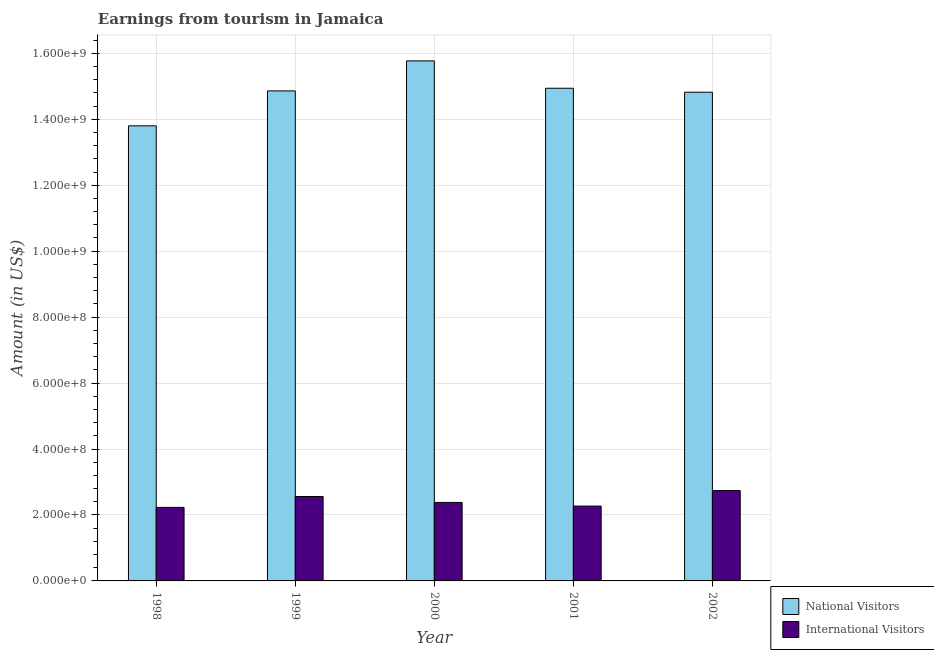How many different coloured bars are there?
Make the answer very short. 2. How many groups of bars are there?
Your answer should be very brief. 5. Are the number of bars on each tick of the X-axis equal?
Your response must be concise. Yes. How many bars are there on the 4th tick from the left?
Offer a terse response. 2. How many bars are there on the 2nd tick from the right?
Give a very brief answer. 2. What is the label of the 5th group of bars from the left?
Offer a very short reply. 2002. In how many cases, is the number of bars for a given year not equal to the number of legend labels?
Offer a terse response. 0. What is the amount earned from national visitors in 2002?
Make the answer very short. 1.48e+09. Across all years, what is the maximum amount earned from national visitors?
Give a very brief answer. 1.58e+09. Across all years, what is the minimum amount earned from national visitors?
Make the answer very short. 1.38e+09. In which year was the amount earned from national visitors maximum?
Your answer should be compact. 2000. What is the total amount earned from international visitors in the graph?
Ensure brevity in your answer.  1.22e+09. What is the difference between the amount earned from international visitors in 1998 and that in 2001?
Your answer should be compact. -4.00e+06. What is the difference between the amount earned from international visitors in 2001 and the amount earned from national visitors in 1998?
Offer a very short reply. 4.00e+06. What is the average amount earned from national visitors per year?
Give a very brief answer. 1.48e+09. In the year 1999, what is the difference between the amount earned from national visitors and amount earned from international visitors?
Provide a succinct answer. 0. In how many years, is the amount earned from international visitors greater than 800000000 US$?
Your answer should be very brief. 0. What is the ratio of the amount earned from national visitors in 2000 to that in 2002?
Offer a terse response. 1.06. What is the difference between the highest and the second highest amount earned from international visitors?
Ensure brevity in your answer.  1.80e+07. What is the difference between the highest and the lowest amount earned from national visitors?
Your answer should be very brief. 1.97e+08. In how many years, is the amount earned from international visitors greater than the average amount earned from international visitors taken over all years?
Keep it short and to the point. 2. Is the sum of the amount earned from international visitors in 2000 and 2002 greater than the maximum amount earned from national visitors across all years?
Your answer should be very brief. Yes. What does the 2nd bar from the left in 2000 represents?
Make the answer very short. International Visitors. What does the 2nd bar from the right in 1998 represents?
Offer a very short reply. National Visitors. How many bars are there?
Make the answer very short. 10. Are all the bars in the graph horizontal?
Keep it short and to the point. No. How many years are there in the graph?
Offer a very short reply. 5. What is the difference between two consecutive major ticks on the Y-axis?
Provide a succinct answer. 2.00e+08. Does the graph contain any zero values?
Offer a terse response. No. How many legend labels are there?
Provide a succinct answer. 2. How are the legend labels stacked?
Provide a succinct answer. Vertical. What is the title of the graph?
Offer a very short reply. Earnings from tourism in Jamaica. What is the label or title of the X-axis?
Your answer should be very brief. Year. What is the label or title of the Y-axis?
Provide a succinct answer. Amount (in US$). What is the Amount (in US$) in National Visitors in 1998?
Give a very brief answer. 1.38e+09. What is the Amount (in US$) in International Visitors in 1998?
Ensure brevity in your answer.  2.23e+08. What is the Amount (in US$) in National Visitors in 1999?
Offer a very short reply. 1.49e+09. What is the Amount (in US$) of International Visitors in 1999?
Provide a short and direct response. 2.56e+08. What is the Amount (in US$) in National Visitors in 2000?
Offer a terse response. 1.58e+09. What is the Amount (in US$) of International Visitors in 2000?
Ensure brevity in your answer.  2.38e+08. What is the Amount (in US$) of National Visitors in 2001?
Give a very brief answer. 1.49e+09. What is the Amount (in US$) in International Visitors in 2001?
Give a very brief answer. 2.27e+08. What is the Amount (in US$) in National Visitors in 2002?
Offer a very short reply. 1.48e+09. What is the Amount (in US$) in International Visitors in 2002?
Keep it short and to the point. 2.74e+08. Across all years, what is the maximum Amount (in US$) of National Visitors?
Your answer should be very brief. 1.58e+09. Across all years, what is the maximum Amount (in US$) of International Visitors?
Offer a very short reply. 2.74e+08. Across all years, what is the minimum Amount (in US$) of National Visitors?
Your response must be concise. 1.38e+09. Across all years, what is the minimum Amount (in US$) of International Visitors?
Provide a short and direct response. 2.23e+08. What is the total Amount (in US$) of National Visitors in the graph?
Your answer should be very brief. 7.42e+09. What is the total Amount (in US$) in International Visitors in the graph?
Ensure brevity in your answer.  1.22e+09. What is the difference between the Amount (in US$) in National Visitors in 1998 and that in 1999?
Offer a terse response. -1.06e+08. What is the difference between the Amount (in US$) in International Visitors in 1998 and that in 1999?
Give a very brief answer. -3.30e+07. What is the difference between the Amount (in US$) of National Visitors in 1998 and that in 2000?
Your answer should be compact. -1.97e+08. What is the difference between the Amount (in US$) of International Visitors in 1998 and that in 2000?
Offer a terse response. -1.50e+07. What is the difference between the Amount (in US$) of National Visitors in 1998 and that in 2001?
Provide a short and direct response. -1.14e+08. What is the difference between the Amount (in US$) in International Visitors in 1998 and that in 2001?
Ensure brevity in your answer.  -4.00e+06. What is the difference between the Amount (in US$) of National Visitors in 1998 and that in 2002?
Give a very brief answer. -1.02e+08. What is the difference between the Amount (in US$) in International Visitors in 1998 and that in 2002?
Offer a very short reply. -5.10e+07. What is the difference between the Amount (in US$) in National Visitors in 1999 and that in 2000?
Make the answer very short. -9.10e+07. What is the difference between the Amount (in US$) in International Visitors in 1999 and that in 2000?
Keep it short and to the point. 1.80e+07. What is the difference between the Amount (in US$) in National Visitors in 1999 and that in 2001?
Make the answer very short. -8.00e+06. What is the difference between the Amount (in US$) of International Visitors in 1999 and that in 2001?
Your answer should be very brief. 2.90e+07. What is the difference between the Amount (in US$) in International Visitors in 1999 and that in 2002?
Make the answer very short. -1.80e+07. What is the difference between the Amount (in US$) in National Visitors in 2000 and that in 2001?
Your response must be concise. 8.30e+07. What is the difference between the Amount (in US$) in International Visitors in 2000 and that in 2001?
Provide a short and direct response. 1.10e+07. What is the difference between the Amount (in US$) in National Visitors in 2000 and that in 2002?
Make the answer very short. 9.50e+07. What is the difference between the Amount (in US$) in International Visitors in 2000 and that in 2002?
Your answer should be very brief. -3.60e+07. What is the difference between the Amount (in US$) of International Visitors in 2001 and that in 2002?
Ensure brevity in your answer.  -4.70e+07. What is the difference between the Amount (in US$) of National Visitors in 1998 and the Amount (in US$) of International Visitors in 1999?
Offer a very short reply. 1.12e+09. What is the difference between the Amount (in US$) in National Visitors in 1998 and the Amount (in US$) in International Visitors in 2000?
Your response must be concise. 1.14e+09. What is the difference between the Amount (in US$) in National Visitors in 1998 and the Amount (in US$) in International Visitors in 2001?
Ensure brevity in your answer.  1.15e+09. What is the difference between the Amount (in US$) of National Visitors in 1998 and the Amount (in US$) of International Visitors in 2002?
Your answer should be compact. 1.11e+09. What is the difference between the Amount (in US$) of National Visitors in 1999 and the Amount (in US$) of International Visitors in 2000?
Keep it short and to the point. 1.25e+09. What is the difference between the Amount (in US$) of National Visitors in 1999 and the Amount (in US$) of International Visitors in 2001?
Keep it short and to the point. 1.26e+09. What is the difference between the Amount (in US$) in National Visitors in 1999 and the Amount (in US$) in International Visitors in 2002?
Provide a short and direct response. 1.21e+09. What is the difference between the Amount (in US$) in National Visitors in 2000 and the Amount (in US$) in International Visitors in 2001?
Offer a very short reply. 1.35e+09. What is the difference between the Amount (in US$) in National Visitors in 2000 and the Amount (in US$) in International Visitors in 2002?
Keep it short and to the point. 1.30e+09. What is the difference between the Amount (in US$) of National Visitors in 2001 and the Amount (in US$) of International Visitors in 2002?
Offer a terse response. 1.22e+09. What is the average Amount (in US$) in National Visitors per year?
Your answer should be compact. 1.48e+09. What is the average Amount (in US$) of International Visitors per year?
Provide a short and direct response. 2.44e+08. In the year 1998, what is the difference between the Amount (in US$) in National Visitors and Amount (in US$) in International Visitors?
Ensure brevity in your answer.  1.16e+09. In the year 1999, what is the difference between the Amount (in US$) in National Visitors and Amount (in US$) in International Visitors?
Give a very brief answer. 1.23e+09. In the year 2000, what is the difference between the Amount (in US$) in National Visitors and Amount (in US$) in International Visitors?
Your response must be concise. 1.34e+09. In the year 2001, what is the difference between the Amount (in US$) in National Visitors and Amount (in US$) in International Visitors?
Ensure brevity in your answer.  1.27e+09. In the year 2002, what is the difference between the Amount (in US$) in National Visitors and Amount (in US$) in International Visitors?
Offer a terse response. 1.21e+09. What is the ratio of the Amount (in US$) of National Visitors in 1998 to that in 1999?
Offer a very short reply. 0.93. What is the ratio of the Amount (in US$) of International Visitors in 1998 to that in 1999?
Give a very brief answer. 0.87. What is the ratio of the Amount (in US$) in National Visitors in 1998 to that in 2000?
Offer a terse response. 0.88. What is the ratio of the Amount (in US$) in International Visitors in 1998 to that in 2000?
Your answer should be compact. 0.94. What is the ratio of the Amount (in US$) in National Visitors in 1998 to that in 2001?
Give a very brief answer. 0.92. What is the ratio of the Amount (in US$) in International Visitors in 1998 to that in 2001?
Make the answer very short. 0.98. What is the ratio of the Amount (in US$) of National Visitors in 1998 to that in 2002?
Ensure brevity in your answer.  0.93. What is the ratio of the Amount (in US$) in International Visitors in 1998 to that in 2002?
Give a very brief answer. 0.81. What is the ratio of the Amount (in US$) in National Visitors in 1999 to that in 2000?
Offer a terse response. 0.94. What is the ratio of the Amount (in US$) in International Visitors in 1999 to that in 2000?
Keep it short and to the point. 1.08. What is the ratio of the Amount (in US$) in National Visitors in 1999 to that in 2001?
Your answer should be very brief. 0.99. What is the ratio of the Amount (in US$) in International Visitors in 1999 to that in 2001?
Make the answer very short. 1.13. What is the ratio of the Amount (in US$) of National Visitors in 1999 to that in 2002?
Provide a succinct answer. 1. What is the ratio of the Amount (in US$) in International Visitors in 1999 to that in 2002?
Keep it short and to the point. 0.93. What is the ratio of the Amount (in US$) of National Visitors in 2000 to that in 2001?
Give a very brief answer. 1.06. What is the ratio of the Amount (in US$) in International Visitors in 2000 to that in 2001?
Ensure brevity in your answer.  1.05. What is the ratio of the Amount (in US$) in National Visitors in 2000 to that in 2002?
Your answer should be very brief. 1.06. What is the ratio of the Amount (in US$) of International Visitors in 2000 to that in 2002?
Offer a terse response. 0.87. What is the ratio of the Amount (in US$) of International Visitors in 2001 to that in 2002?
Offer a terse response. 0.83. What is the difference between the highest and the second highest Amount (in US$) in National Visitors?
Provide a succinct answer. 8.30e+07. What is the difference between the highest and the second highest Amount (in US$) of International Visitors?
Offer a terse response. 1.80e+07. What is the difference between the highest and the lowest Amount (in US$) in National Visitors?
Give a very brief answer. 1.97e+08. What is the difference between the highest and the lowest Amount (in US$) of International Visitors?
Your answer should be very brief. 5.10e+07. 